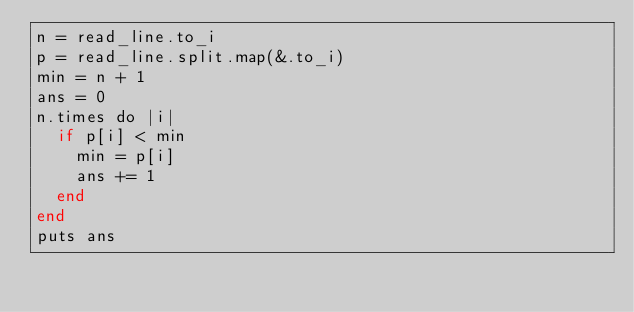Convert code to text. <code><loc_0><loc_0><loc_500><loc_500><_Crystal_>n = read_line.to_i
p = read_line.split.map(&.to_i)
min = n + 1
ans = 0
n.times do |i|
  if p[i] < min
    min = p[i]
    ans += 1
  end
end
puts ans
</code> 